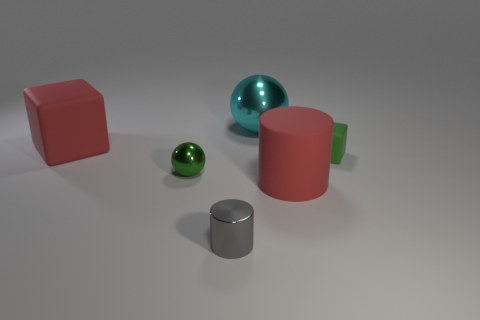Subtract 1 spheres. How many spheres are left? 1 Subtract all red balls. Subtract all gray blocks. How many balls are left? 2 Subtract all blue cylinders. How many green spheres are left? 1 Subtract all tiny green matte objects. Subtract all small objects. How many objects are left? 2 Add 6 small gray metal objects. How many small gray metal objects are left? 7 Add 4 tiny green metallic balls. How many tiny green metallic balls exist? 5 Add 1 large rubber cylinders. How many objects exist? 7 Subtract 1 gray cylinders. How many objects are left? 5 Subtract all cylinders. How many objects are left? 4 